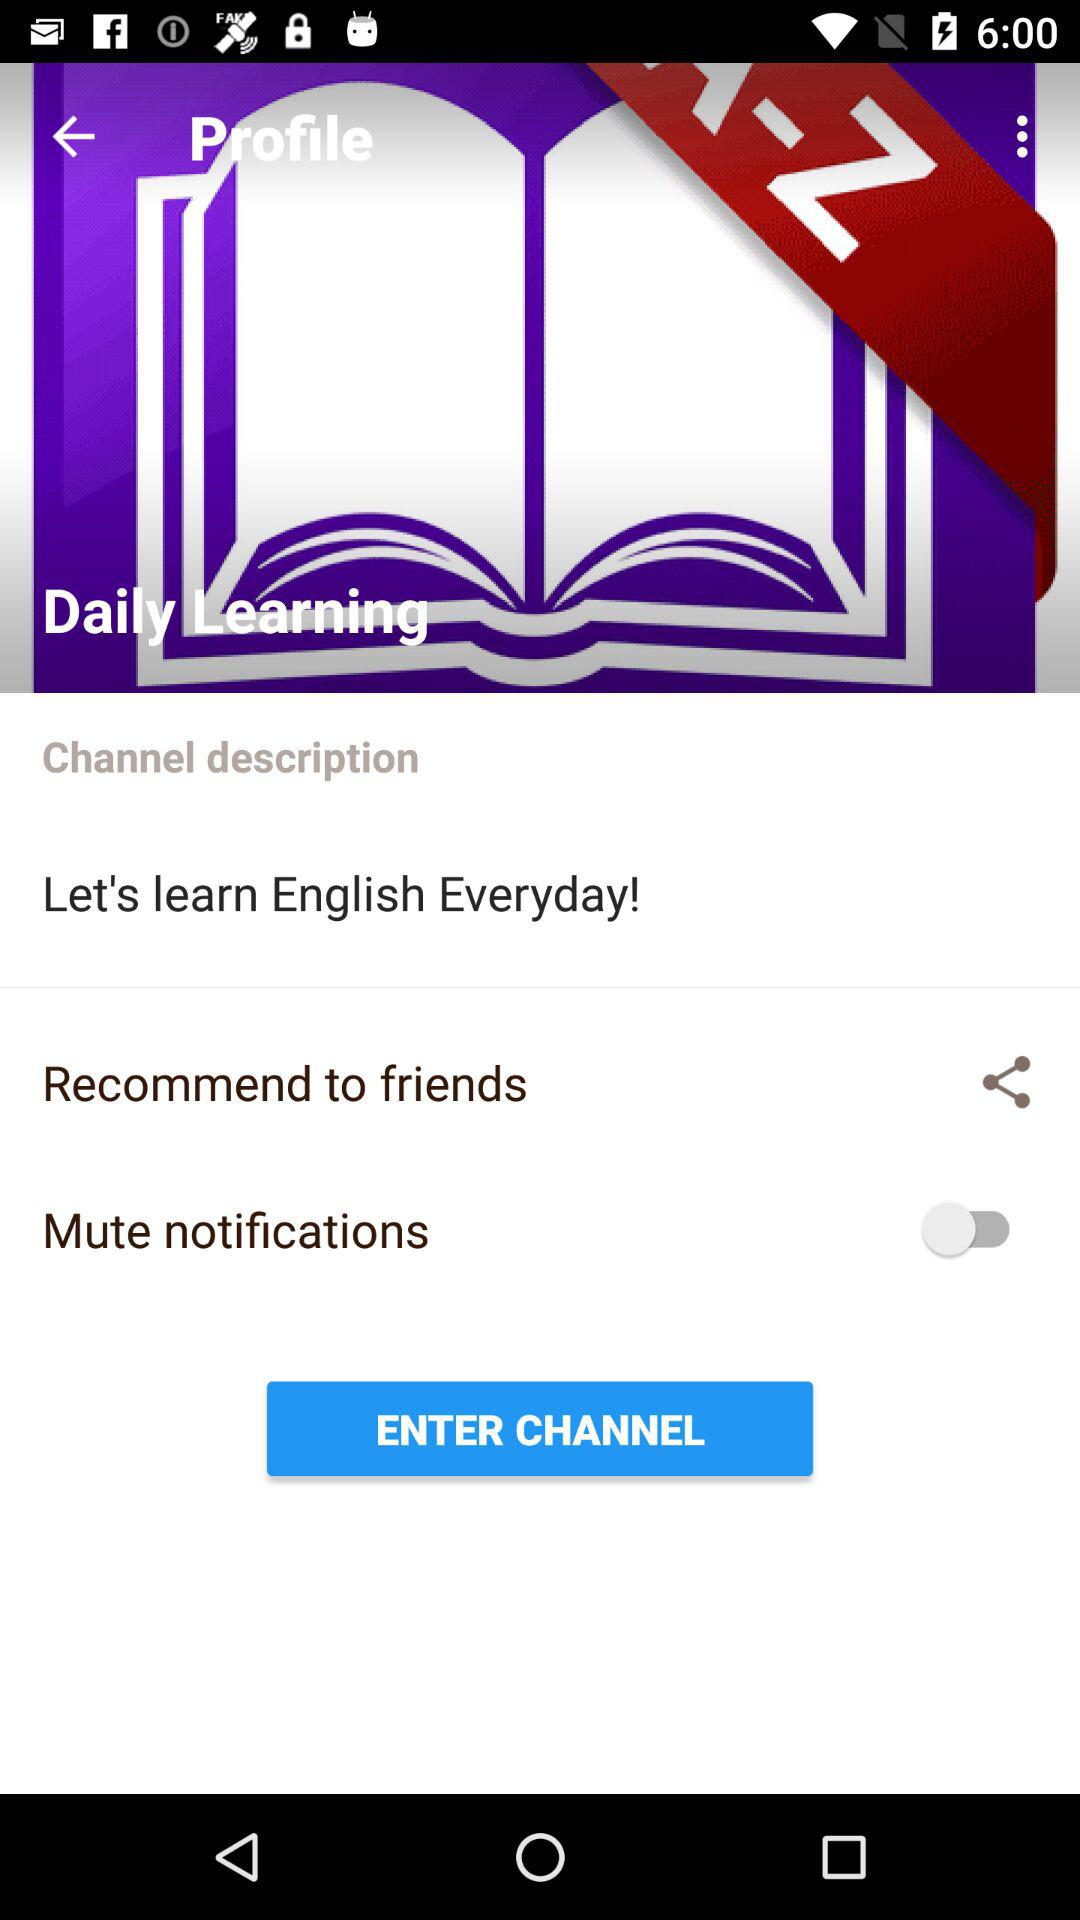Through which applications can this information be shared?
When the provided information is insufficient, respond with <no answer>. <no answer> 